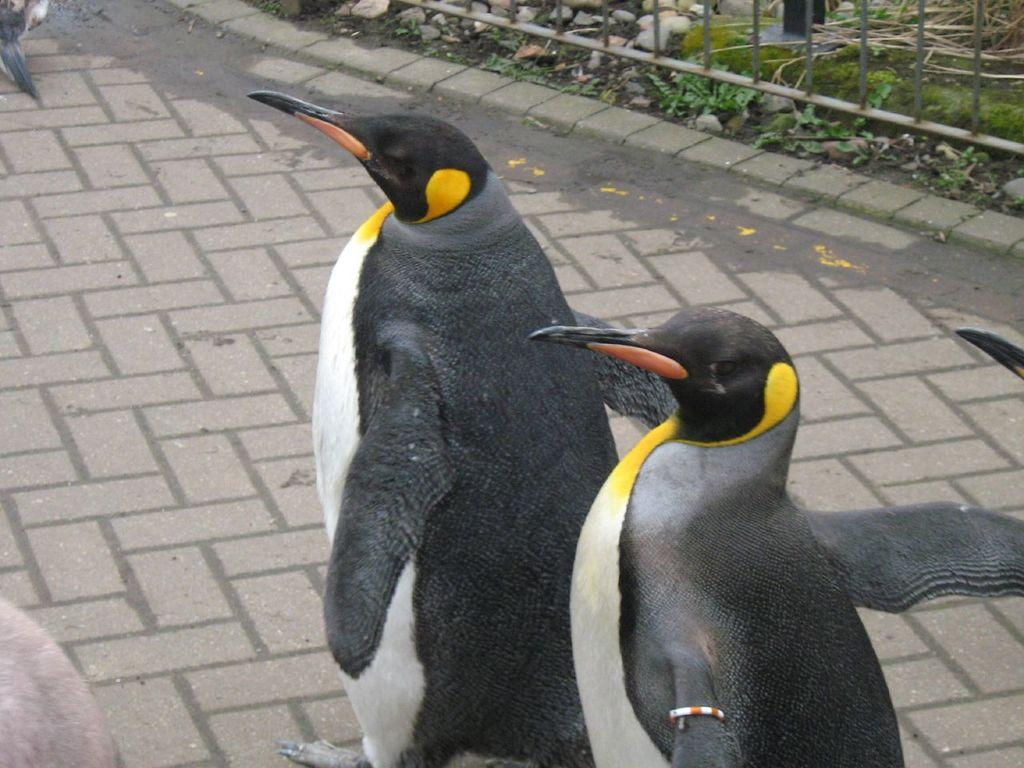What animals can be seen in the image? There are penguins on a walkway in the image. What is located on the right side of the penguins? There are plants and stones on the right side of the penguins. What type of barrier is present on the right side of the penguins? There is an iron grille on the right side of the penguins. What type of clock can be seen hanging from the iron grille in the image? There is no clock present in the image; it only features penguins, plants, stones, and an iron grille. 